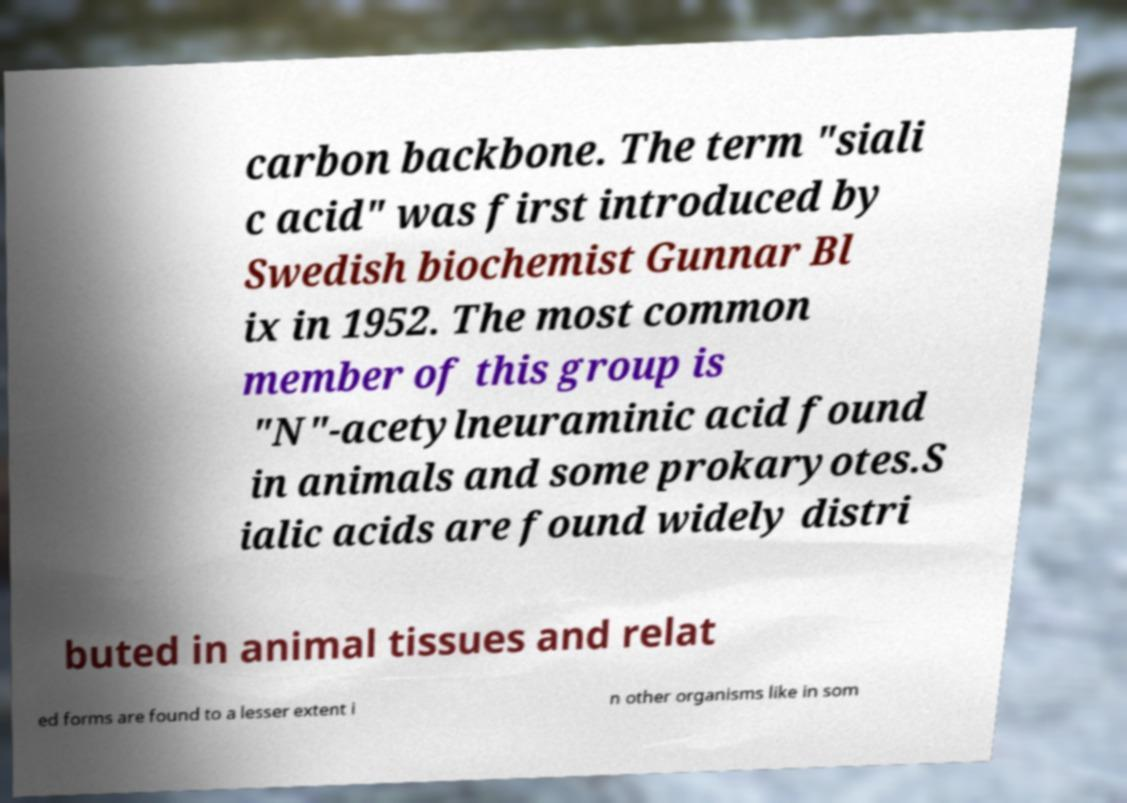Please read and relay the text visible in this image. What does it say? carbon backbone. The term "siali c acid" was first introduced by Swedish biochemist Gunnar Bl ix in 1952. The most common member of this group is "N"-acetylneuraminic acid found in animals and some prokaryotes.S ialic acids are found widely distri buted in animal tissues and relat ed forms are found to a lesser extent i n other organisms like in som 